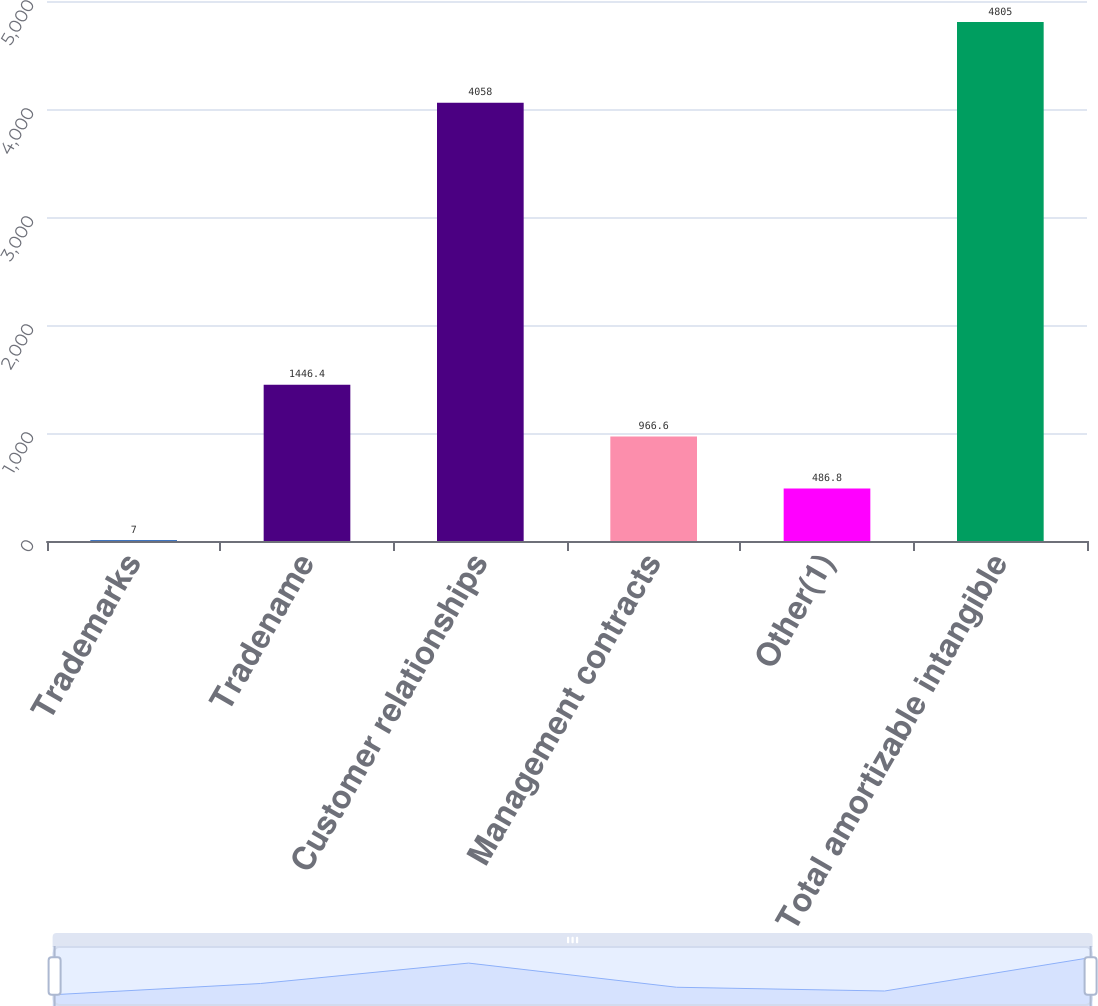Convert chart. <chart><loc_0><loc_0><loc_500><loc_500><bar_chart><fcel>Trademarks<fcel>Tradename<fcel>Customer relationships<fcel>Management contracts<fcel>Other(1)<fcel>Total amortizable intangible<nl><fcel>7<fcel>1446.4<fcel>4058<fcel>966.6<fcel>486.8<fcel>4805<nl></chart> 